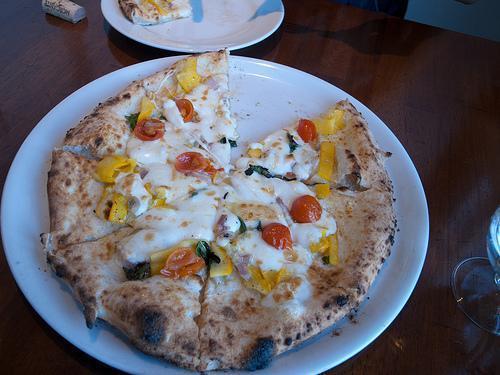How many plates are in the picture?
Give a very brief answer. 2. How many slices of pizza are missing from the whole?
Give a very brief answer. 1. 